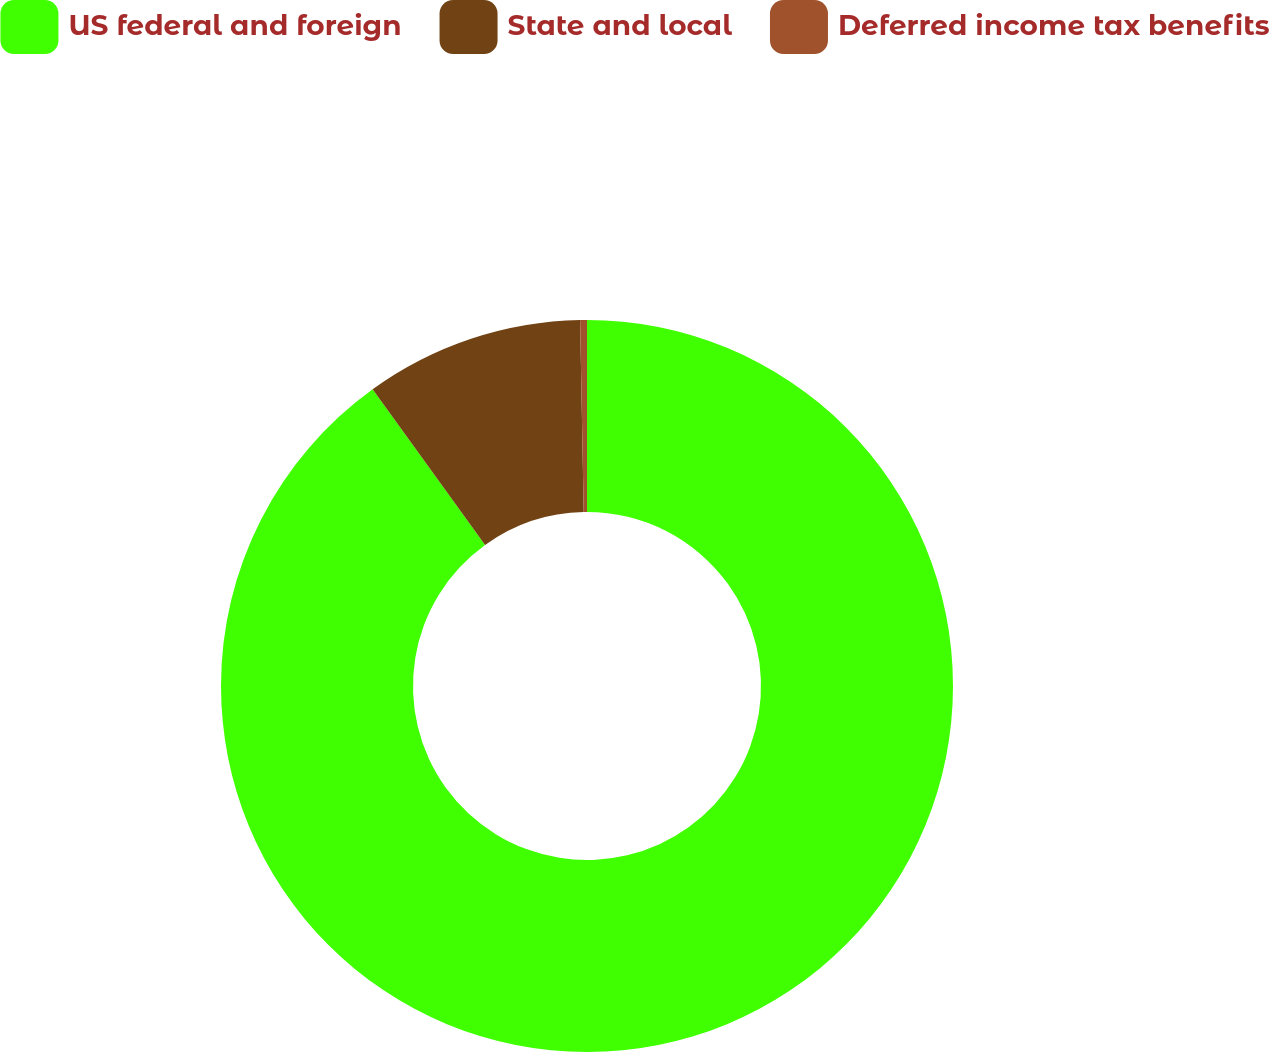Convert chart to OTSL. <chart><loc_0><loc_0><loc_500><loc_500><pie_chart><fcel>US federal and foreign<fcel>State and local<fcel>Deferred income tax benefits<nl><fcel>90.04%<fcel>9.66%<fcel>0.3%<nl></chart> 